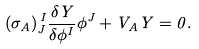<formula> <loc_0><loc_0><loc_500><loc_500>( \sigma _ { A } ) _ { J } ^ { \, I } \frac { \delta Y } { \delta \phi ^ { I } } \phi ^ { J } + V _ { A } Y = 0 .</formula> 